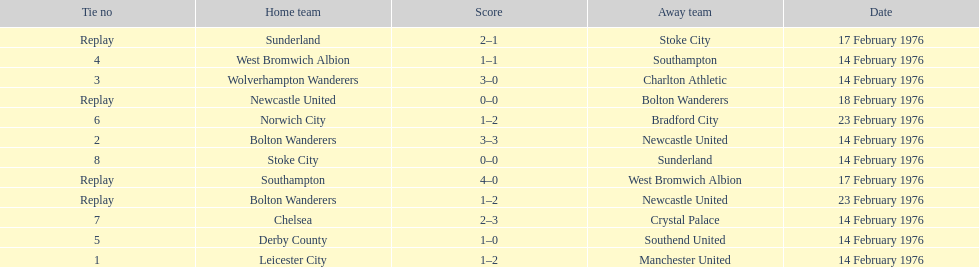How many teams played on february 14th, 1976? 7. 